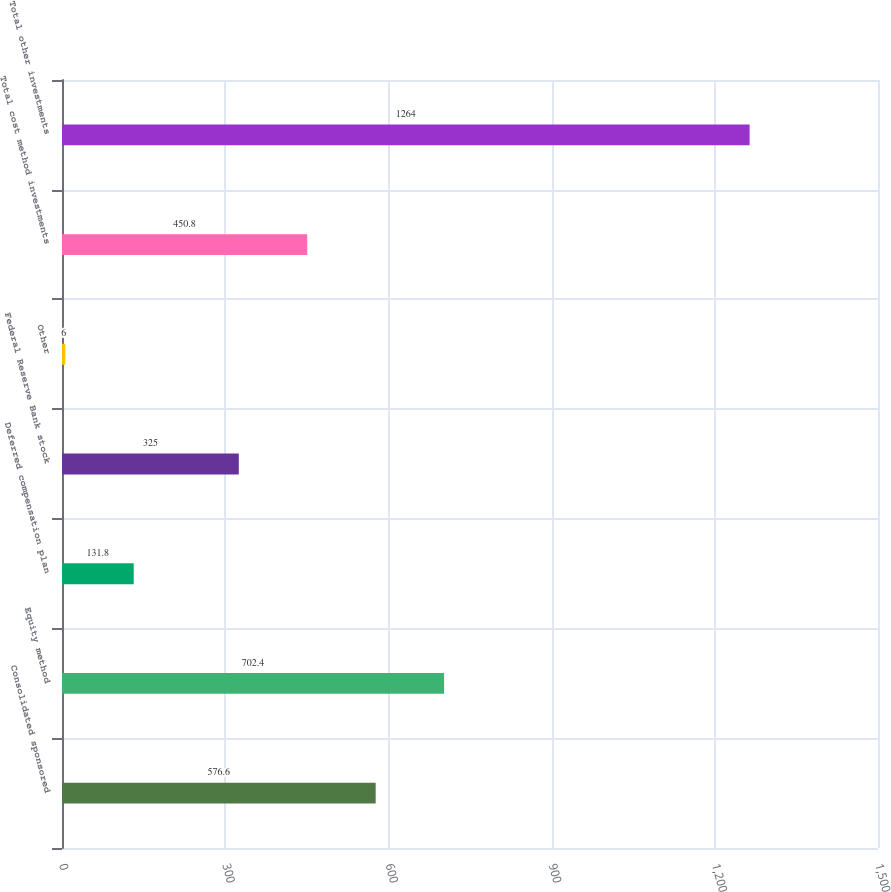Convert chart to OTSL. <chart><loc_0><loc_0><loc_500><loc_500><bar_chart><fcel>Consolidated sponsored<fcel>Equity method<fcel>Deferred compensation plan<fcel>Federal Reserve Bank stock<fcel>Other<fcel>Total cost method investments<fcel>Total other investments<nl><fcel>576.6<fcel>702.4<fcel>131.8<fcel>325<fcel>6<fcel>450.8<fcel>1264<nl></chart> 